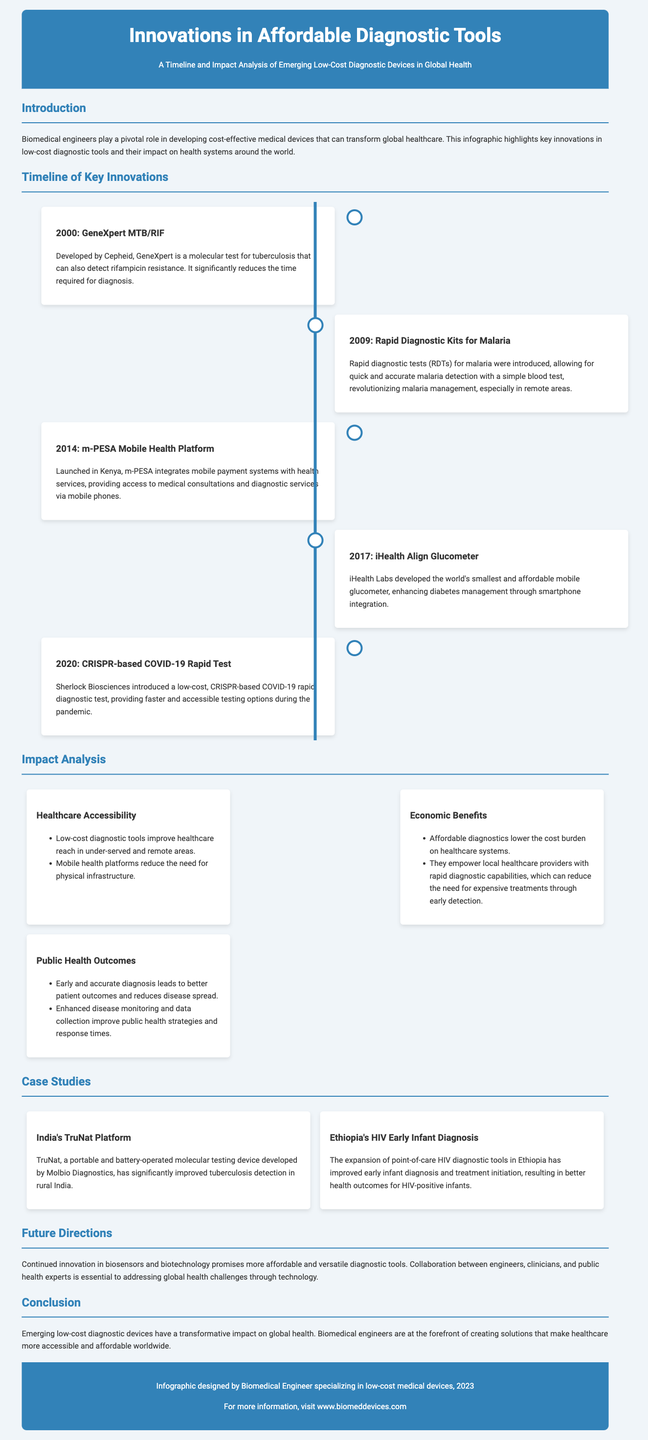what year was the GeneXpert MTB/RIF developed? The document specifies that the GeneXpert MTB/RIF was developed in the year 2000.
Answer: 2000 what is the main purpose of the m-PESA Mobile Health Platform? The m-PESA Mobile Health Platform integrates mobile payment systems with health services.
Answer: Access to medical consultations what medical condition does the iHealth Align Glucometer help manage? The iHealth Align Glucometer is specifically designed to enhance diabetes management.
Answer: Diabetes how many impact areas are mentioned in the impact analysis section? The impact analysis section mentions three areas: Healthcare Accessibility, Economic Benefits, and Public Health Outcomes.
Answer: Three which country introduced the CRISPR-based COVID-19 Rapid Test? The document mentions that Sherlock Biosciences introduced the CRISPR-based COVID-19 Rapid Test.
Answer: USA what is one of the benefits of low-cost diagnostic tools according to the impact analysis? Low-cost diagnostic tools lower the cost burden on healthcare systems.
Answer: Lower cost burden what device significantly improved tuberculosis detection in India? The document states that the TruNat platform significantly improved tuberculosis detection in India.
Answer: TruNat platform what does the infographic predict about the future of diagnostic tools? The infographic predicts that continued innovation will promise more affordable and versatile diagnostic tools.
Answer: Affordable and versatile diagnostic tools 